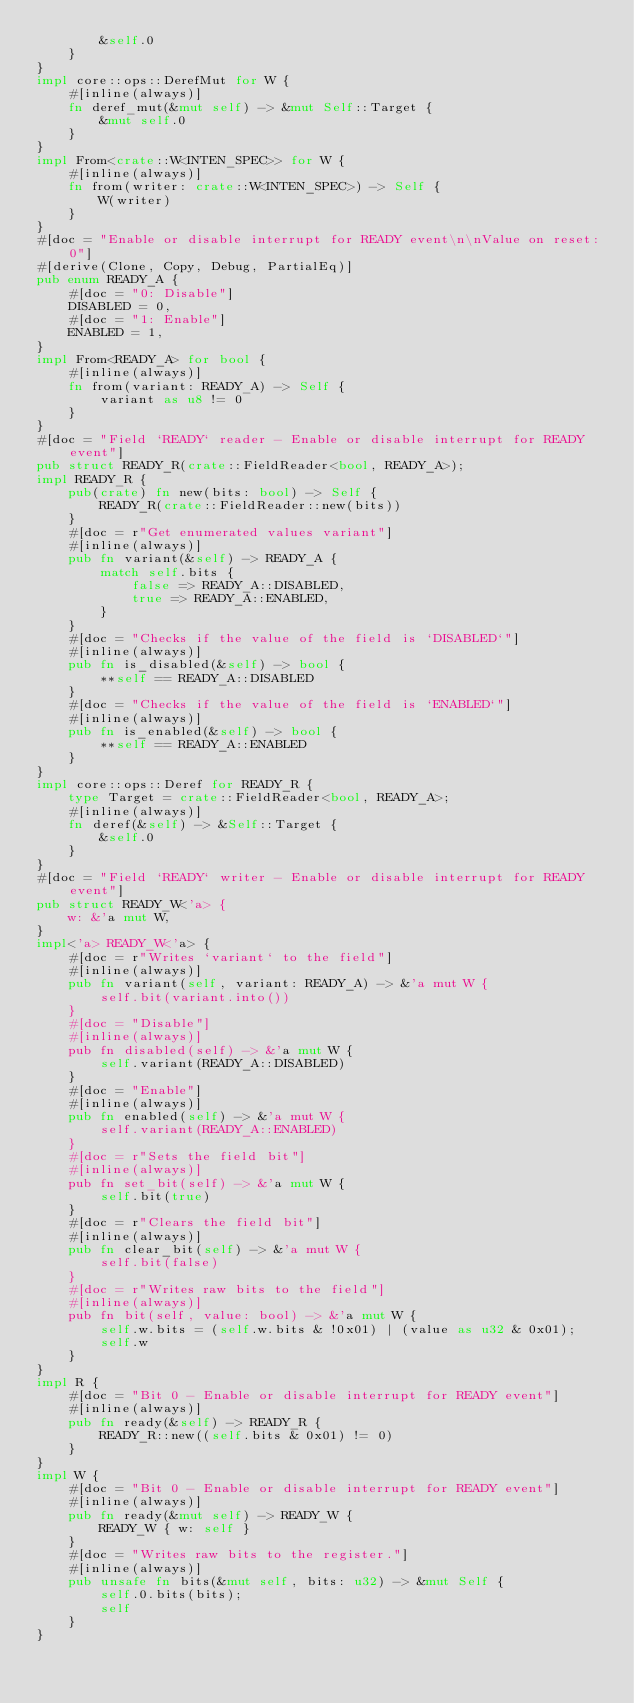<code> <loc_0><loc_0><loc_500><loc_500><_Rust_>        &self.0
    }
}
impl core::ops::DerefMut for W {
    #[inline(always)]
    fn deref_mut(&mut self) -> &mut Self::Target {
        &mut self.0
    }
}
impl From<crate::W<INTEN_SPEC>> for W {
    #[inline(always)]
    fn from(writer: crate::W<INTEN_SPEC>) -> Self {
        W(writer)
    }
}
#[doc = "Enable or disable interrupt for READY event\n\nValue on reset: 0"]
#[derive(Clone, Copy, Debug, PartialEq)]
pub enum READY_A {
    #[doc = "0: Disable"]
    DISABLED = 0,
    #[doc = "1: Enable"]
    ENABLED = 1,
}
impl From<READY_A> for bool {
    #[inline(always)]
    fn from(variant: READY_A) -> Self {
        variant as u8 != 0
    }
}
#[doc = "Field `READY` reader - Enable or disable interrupt for READY event"]
pub struct READY_R(crate::FieldReader<bool, READY_A>);
impl READY_R {
    pub(crate) fn new(bits: bool) -> Self {
        READY_R(crate::FieldReader::new(bits))
    }
    #[doc = r"Get enumerated values variant"]
    #[inline(always)]
    pub fn variant(&self) -> READY_A {
        match self.bits {
            false => READY_A::DISABLED,
            true => READY_A::ENABLED,
        }
    }
    #[doc = "Checks if the value of the field is `DISABLED`"]
    #[inline(always)]
    pub fn is_disabled(&self) -> bool {
        **self == READY_A::DISABLED
    }
    #[doc = "Checks if the value of the field is `ENABLED`"]
    #[inline(always)]
    pub fn is_enabled(&self) -> bool {
        **self == READY_A::ENABLED
    }
}
impl core::ops::Deref for READY_R {
    type Target = crate::FieldReader<bool, READY_A>;
    #[inline(always)]
    fn deref(&self) -> &Self::Target {
        &self.0
    }
}
#[doc = "Field `READY` writer - Enable or disable interrupt for READY event"]
pub struct READY_W<'a> {
    w: &'a mut W,
}
impl<'a> READY_W<'a> {
    #[doc = r"Writes `variant` to the field"]
    #[inline(always)]
    pub fn variant(self, variant: READY_A) -> &'a mut W {
        self.bit(variant.into())
    }
    #[doc = "Disable"]
    #[inline(always)]
    pub fn disabled(self) -> &'a mut W {
        self.variant(READY_A::DISABLED)
    }
    #[doc = "Enable"]
    #[inline(always)]
    pub fn enabled(self) -> &'a mut W {
        self.variant(READY_A::ENABLED)
    }
    #[doc = r"Sets the field bit"]
    #[inline(always)]
    pub fn set_bit(self) -> &'a mut W {
        self.bit(true)
    }
    #[doc = r"Clears the field bit"]
    #[inline(always)]
    pub fn clear_bit(self) -> &'a mut W {
        self.bit(false)
    }
    #[doc = r"Writes raw bits to the field"]
    #[inline(always)]
    pub fn bit(self, value: bool) -> &'a mut W {
        self.w.bits = (self.w.bits & !0x01) | (value as u32 & 0x01);
        self.w
    }
}
impl R {
    #[doc = "Bit 0 - Enable or disable interrupt for READY event"]
    #[inline(always)]
    pub fn ready(&self) -> READY_R {
        READY_R::new((self.bits & 0x01) != 0)
    }
}
impl W {
    #[doc = "Bit 0 - Enable or disable interrupt for READY event"]
    #[inline(always)]
    pub fn ready(&mut self) -> READY_W {
        READY_W { w: self }
    }
    #[doc = "Writes raw bits to the register."]
    #[inline(always)]
    pub unsafe fn bits(&mut self, bits: u32) -> &mut Self {
        self.0.bits(bits);
        self
    }
}</code> 